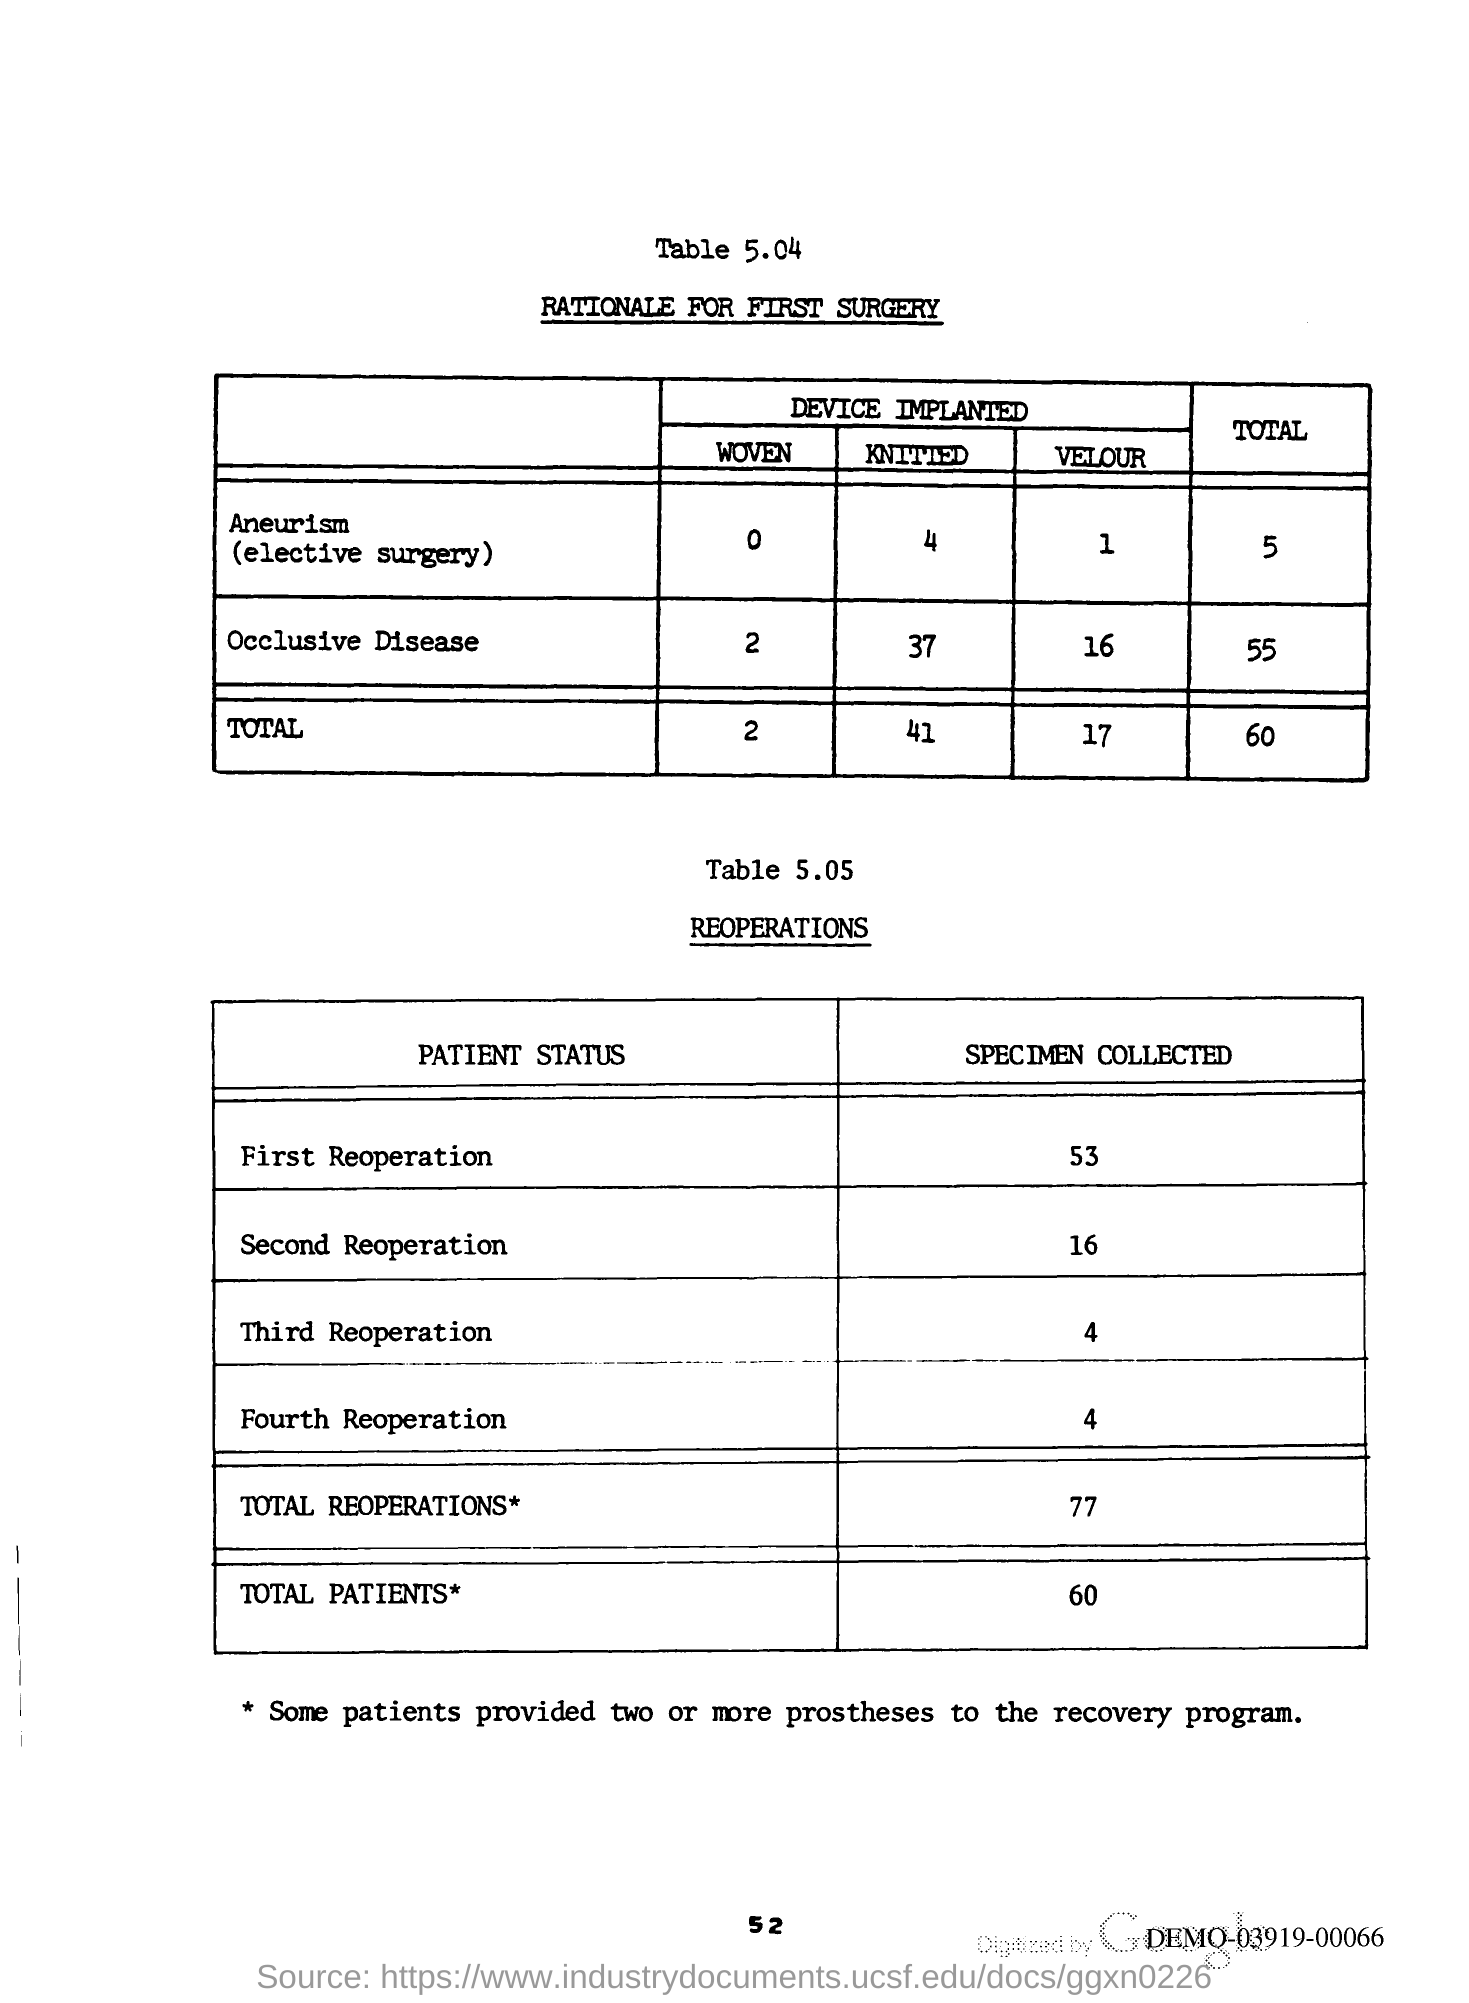Highlight a few significant elements in this photo. The total reoperations is 77. A total of 53 specimens were collected for the first reoperation. As of February 2023, the total number of patients is 60. 